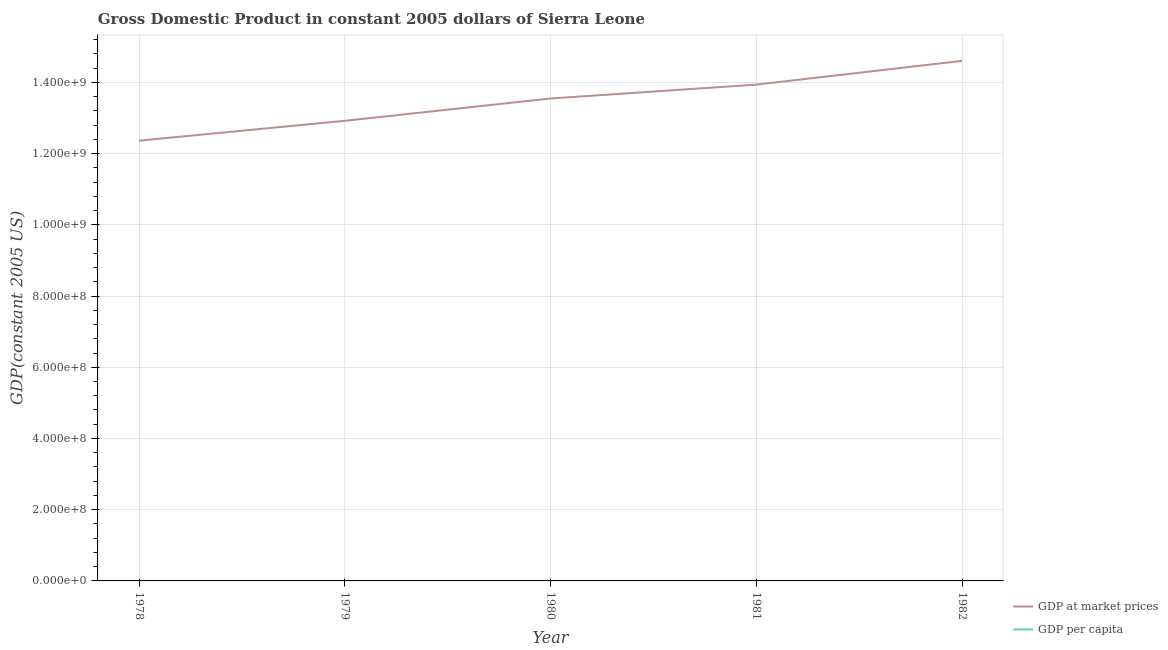What is the gdp at market prices in 1981?
Your response must be concise. 1.39e+09. Across all years, what is the maximum gdp per capita?
Keep it short and to the point. 452.94. Across all years, what is the minimum gdp at market prices?
Keep it short and to the point. 1.24e+09. In which year was the gdp per capita maximum?
Provide a succinct answer. 1982. In which year was the gdp per capita minimum?
Make the answer very short. 1978. What is the total gdp at market prices in the graph?
Offer a terse response. 6.74e+09. What is the difference between the gdp per capita in 1979 and that in 1980?
Offer a terse response. -10.74. What is the difference between the gdp at market prices in 1980 and the gdp per capita in 1978?
Your answer should be compact. 1.35e+09. What is the average gdp at market prices per year?
Your answer should be compact. 1.35e+09. In the year 1982, what is the difference between the gdp per capita and gdp at market prices?
Give a very brief answer. -1.46e+09. In how many years, is the gdp at market prices greater than 440000000 US$?
Ensure brevity in your answer.  5. What is the ratio of the gdp at market prices in 1978 to that in 1979?
Your answer should be very brief. 0.96. Is the gdp at market prices in 1979 less than that in 1982?
Give a very brief answer. Yes. What is the difference between the highest and the second highest gdp at market prices?
Give a very brief answer. 6.66e+07. What is the difference between the highest and the lowest gdp at market prices?
Make the answer very short. 2.24e+08. In how many years, is the gdp per capita greater than the average gdp per capita taken over all years?
Keep it short and to the point. 3. Is the gdp per capita strictly less than the gdp at market prices over the years?
Keep it short and to the point. Yes. How many lines are there?
Your response must be concise. 2. What is the difference between two consecutive major ticks on the Y-axis?
Give a very brief answer. 2.00e+08. Are the values on the major ticks of Y-axis written in scientific E-notation?
Offer a very short reply. Yes. Does the graph contain any zero values?
Your response must be concise. No. Does the graph contain grids?
Provide a succinct answer. Yes. Where does the legend appear in the graph?
Make the answer very short. Bottom right. What is the title of the graph?
Make the answer very short. Gross Domestic Product in constant 2005 dollars of Sierra Leone. What is the label or title of the X-axis?
Your answer should be very brief. Year. What is the label or title of the Y-axis?
Your answer should be compact. GDP(constant 2005 US). What is the GDP(constant 2005 US) of GDP at market prices in 1978?
Give a very brief answer. 1.24e+09. What is the GDP(constant 2005 US) of GDP per capita in 1978?
Your response must be concise. 418.97. What is the GDP(constant 2005 US) of GDP at market prices in 1979?
Your answer should be very brief. 1.29e+09. What is the GDP(constant 2005 US) of GDP per capita in 1979?
Offer a terse response. 428.2. What is the GDP(constant 2005 US) of GDP at market prices in 1980?
Ensure brevity in your answer.  1.35e+09. What is the GDP(constant 2005 US) of GDP per capita in 1980?
Give a very brief answer. 438.94. What is the GDP(constant 2005 US) of GDP at market prices in 1981?
Provide a succinct answer. 1.39e+09. What is the GDP(constant 2005 US) in GDP per capita in 1981?
Your response must be concise. 441.72. What is the GDP(constant 2005 US) of GDP at market prices in 1982?
Your answer should be very brief. 1.46e+09. What is the GDP(constant 2005 US) of GDP per capita in 1982?
Give a very brief answer. 452.94. Across all years, what is the maximum GDP(constant 2005 US) of GDP at market prices?
Ensure brevity in your answer.  1.46e+09. Across all years, what is the maximum GDP(constant 2005 US) of GDP per capita?
Provide a short and direct response. 452.94. Across all years, what is the minimum GDP(constant 2005 US) of GDP at market prices?
Provide a short and direct response. 1.24e+09. Across all years, what is the minimum GDP(constant 2005 US) of GDP per capita?
Provide a short and direct response. 418.97. What is the total GDP(constant 2005 US) in GDP at market prices in the graph?
Offer a terse response. 6.74e+09. What is the total GDP(constant 2005 US) in GDP per capita in the graph?
Your answer should be compact. 2180.76. What is the difference between the GDP(constant 2005 US) in GDP at market prices in 1978 and that in 1979?
Your answer should be compact. -5.58e+07. What is the difference between the GDP(constant 2005 US) in GDP per capita in 1978 and that in 1979?
Your answer should be very brief. -9.23. What is the difference between the GDP(constant 2005 US) of GDP at market prices in 1978 and that in 1980?
Your response must be concise. -1.18e+08. What is the difference between the GDP(constant 2005 US) in GDP per capita in 1978 and that in 1980?
Ensure brevity in your answer.  -19.97. What is the difference between the GDP(constant 2005 US) of GDP at market prices in 1978 and that in 1981?
Give a very brief answer. -1.57e+08. What is the difference between the GDP(constant 2005 US) of GDP per capita in 1978 and that in 1981?
Keep it short and to the point. -22.75. What is the difference between the GDP(constant 2005 US) in GDP at market prices in 1978 and that in 1982?
Provide a succinct answer. -2.24e+08. What is the difference between the GDP(constant 2005 US) of GDP per capita in 1978 and that in 1982?
Provide a short and direct response. -33.97. What is the difference between the GDP(constant 2005 US) in GDP at market prices in 1979 and that in 1980?
Your response must be concise. -6.26e+07. What is the difference between the GDP(constant 2005 US) of GDP per capita in 1979 and that in 1980?
Offer a terse response. -10.74. What is the difference between the GDP(constant 2005 US) in GDP at market prices in 1979 and that in 1981?
Your answer should be compact. -1.02e+08. What is the difference between the GDP(constant 2005 US) of GDP per capita in 1979 and that in 1981?
Give a very brief answer. -13.52. What is the difference between the GDP(constant 2005 US) in GDP at market prices in 1979 and that in 1982?
Your answer should be compact. -1.68e+08. What is the difference between the GDP(constant 2005 US) in GDP per capita in 1979 and that in 1982?
Your answer should be very brief. -24.74. What is the difference between the GDP(constant 2005 US) of GDP at market prices in 1980 and that in 1981?
Make the answer very short. -3.90e+07. What is the difference between the GDP(constant 2005 US) of GDP per capita in 1980 and that in 1981?
Your answer should be very brief. -2.78. What is the difference between the GDP(constant 2005 US) of GDP at market prices in 1980 and that in 1982?
Your answer should be compact. -1.06e+08. What is the difference between the GDP(constant 2005 US) of GDP per capita in 1980 and that in 1982?
Offer a terse response. -14. What is the difference between the GDP(constant 2005 US) of GDP at market prices in 1981 and that in 1982?
Your answer should be very brief. -6.66e+07. What is the difference between the GDP(constant 2005 US) in GDP per capita in 1981 and that in 1982?
Give a very brief answer. -11.22. What is the difference between the GDP(constant 2005 US) of GDP at market prices in 1978 and the GDP(constant 2005 US) of GDP per capita in 1979?
Offer a terse response. 1.24e+09. What is the difference between the GDP(constant 2005 US) of GDP at market prices in 1978 and the GDP(constant 2005 US) of GDP per capita in 1980?
Your answer should be very brief. 1.24e+09. What is the difference between the GDP(constant 2005 US) in GDP at market prices in 1978 and the GDP(constant 2005 US) in GDP per capita in 1981?
Give a very brief answer. 1.24e+09. What is the difference between the GDP(constant 2005 US) in GDP at market prices in 1978 and the GDP(constant 2005 US) in GDP per capita in 1982?
Offer a terse response. 1.24e+09. What is the difference between the GDP(constant 2005 US) in GDP at market prices in 1979 and the GDP(constant 2005 US) in GDP per capita in 1980?
Offer a terse response. 1.29e+09. What is the difference between the GDP(constant 2005 US) in GDP at market prices in 1979 and the GDP(constant 2005 US) in GDP per capita in 1981?
Keep it short and to the point. 1.29e+09. What is the difference between the GDP(constant 2005 US) of GDP at market prices in 1979 and the GDP(constant 2005 US) of GDP per capita in 1982?
Offer a very short reply. 1.29e+09. What is the difference between the GDP(constant 2005 US) in GDP at market prices in 1980 and the GDP(constant 2005 US) in GDP per capita in 1981?
Your answer should be compact. 1.35e+09. What is the difference between the GDP(constant 2005 US) in GDP at market prices in 1980 and the GDP(constant 2005 US) in GDP per capita in 1982?
Keep it short and to the point. 1.35e+09. What is the difference between the GDP(constant 2005 US) of GDP at market prices in 1981 and the GDP(constant 2005 US) of GDP per capita in 1982?
Provide a succinct answer. 1.39e+09. What is the average GDP(constant 2005 US) of GDP at market prices per year?
Offer a very short reply. 1.35e+09. What is the average GDP(constant 2005 US) in GDP per capita per year?
Provide a succinct answer. 436.15. In the year 1978, what is the difference between the GDP(constant 2005 US) in GDP at market prices and GDP(constant 2005 US) in GDP per capita?
Keep it short and to the point. 1.24e+09. In the year 1979, what is the difference between the GDP(constant 2005 US) in GDP at market prices and GDP(constant 2005 US) in GDP per capita?
Provide a short and direct response. 1.29e+09. In the year 1980, what is the difference between the GDP(constant 2005 US) of GDP at market prices and GDP(constant 2005 US) of GDP per capita?
Provide a short and direct response. 1.35e+09. In the year 1981, what is the difference between the GDP(constant 2005 US) of GDP at market prices and GDP(constant 2005 US) of GDP per capita?
Provide a short and direct response. 1.39e+09. In the year 1982, what is the difference between the GDP(constant 2005 US) in GDP at market prices and GDP(constant 2005 US) in GDP per capita?
Offer a terse response. 1.46e+09. What is the ratio of the GDP(constant 2005 US) of GDP at market prices in 1978 to that in 1979?
Offer a very short reply. 0.96. What is the ratio of the GDP(constant 2005 US) of GDP per capita in 1978 to that in 1979?
Your response must be concise. 0.98. What is the ratio of the GDP(constant 2005 US) in GDP at market prices in 1978 to that in 1980?
Your answer should be very brief. 0.91. What is the ratio of the GDP(constant 2005 US) of GDP per capita in 1978 to that in 1980?
Your response must be concise. 0.95. What is the ratio of the GDP(constant 2005 US) in GDP at market prices in 1978 to that in 1981?
Keep it short and to the point. 0.89. What is the ratio of the GDP(constant 2005 US) of GDP per capita in 1978 to that in 1981?
Provide a short and direct response. 0.95. What is the ratio of the GDP(constant 2005 US) of GDP at market prices in 1978 to that in 1982?
Give a very brief answer. 0.85. What is the ratio of the GDP(constant 2005 US) in GDP per capita in 1978 to that in 1982?
Your answer should be very brief. 0.93. What is the ratio of the GDP(constant 2005 US) of GDP at market prices in 1979 to that in 1980?
Make the answer very short. 0.95. What is the ratio of the GDP(constant 2005 US) of GDP per capita in 1979 to that in 1980?
Give a very brief answer. 0.98. What is the ratio of the GDP(constant 2005 US) of GDP at market prices in 1979 to that in 1981?
Your answer should be compact. 0.93. What is the ratio of the GDP(constant 2005 US) in GDP per capita in 1979 to that in 1981?
Give a very brief answer. 0.97. What is the ratio of the GDP(constant 2005 US) of GDP at market prices in 1979 to that in 1982?
Your answer should be very brief. 0.88. What is the ratio of the GDP(constant 2005 US) in GDP per capita in 1979 to that in 1982?
Offer a very short reply. 0.95. What is the ratio of the GDP(constant 2005 US) in GDP at market prices in 1980 to that in 1982?
Your answer should be very brief. 0.93. What is the ratio of the GDP(constant 2005 US) of GDP per capita in 1980 to that in 1982?
Provide a short and direct response. 0.97. What is the ratio of the GDP(constant 2005 US) of GDP at market prices in 1981 to that in 1982?
Provide a succinct answer. 0.95. What is the ratio of the GDP(constant 2005 US) in GDP per capita in 1981 to that in 1982?
Make the answer very short. 0.98. What is the difference between the highest and the second highest GDP(constant 2005 US) of GDP at market prices?
Your response must be concise. 6.66e+07. What is the difference between the highest and the second highest GDP(constant 2005 US) of GDP per capita?
Your answer should be very brief. 11.22. What is the difference between the highest and the lowest GDP(constant 2005 US) in GDP at market prices?
Offer a very short reply. 2.24e+08. What is the difference between the highest and the lowest GDP(constant 2005 US) in GDP per capita?
Make the answer very short. 33.97. 